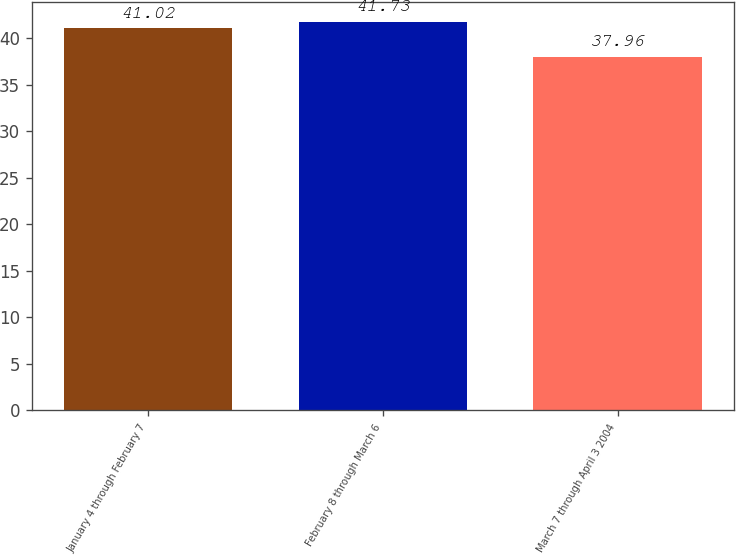Convert chart to OTSL. <chart><loc_0><loc_0><loc_500><loc_500><bar_chart><fcel>January 4 through February 7<fcel>February 8 through March 6<fcel>March 7 through April 3 2004<nl><fcel>41.02<fcel>41.73<fcel>37.96<nl></chart> 